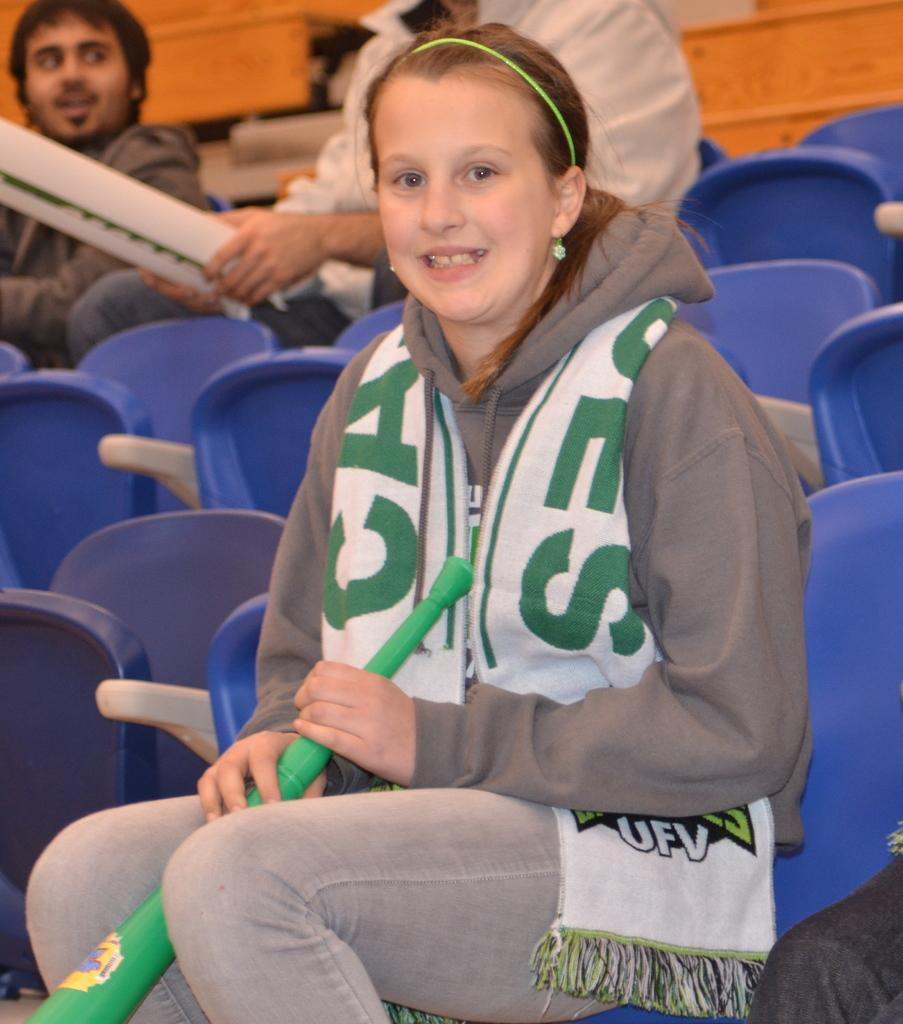Provide a one-sentence caption for the provided image. A girl wearing a white and green UFV scarf is seating on a blue plastic chair. 